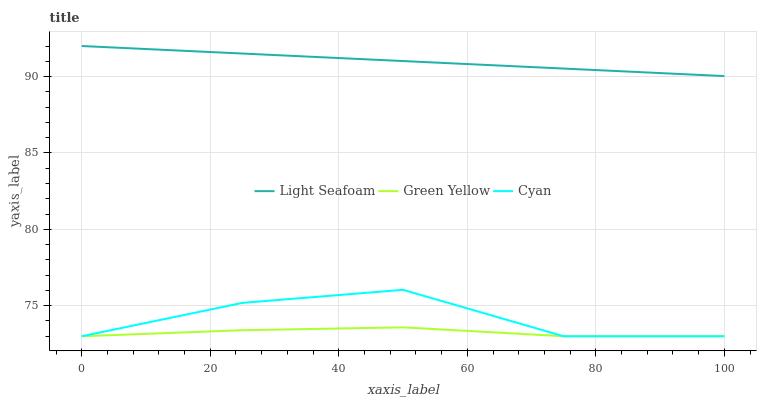Does Light Seafoam have the minimum area under the curve?
Answer yes or no. No. Does Green Yellow have the maximum area under the curve?
Answer yes or no. No. Is Green Yellow the smoothest?
Answer yes or no. No. Is Green Yellow the roughest?
Answer yes or no. No. Does Light Seafoam have the lowest value?
Answer yes or no. No. Does Green Yellow have the highest value?
Answer yes or no. No. Is Cyan less than Light Seafoam?
Answer yes or no. Yes. Is Light Seafoam greater than Cyan?
Answer yes or no. Yes. Does Cyan intersect Light Seafoam?
Answer yes or no. No. 